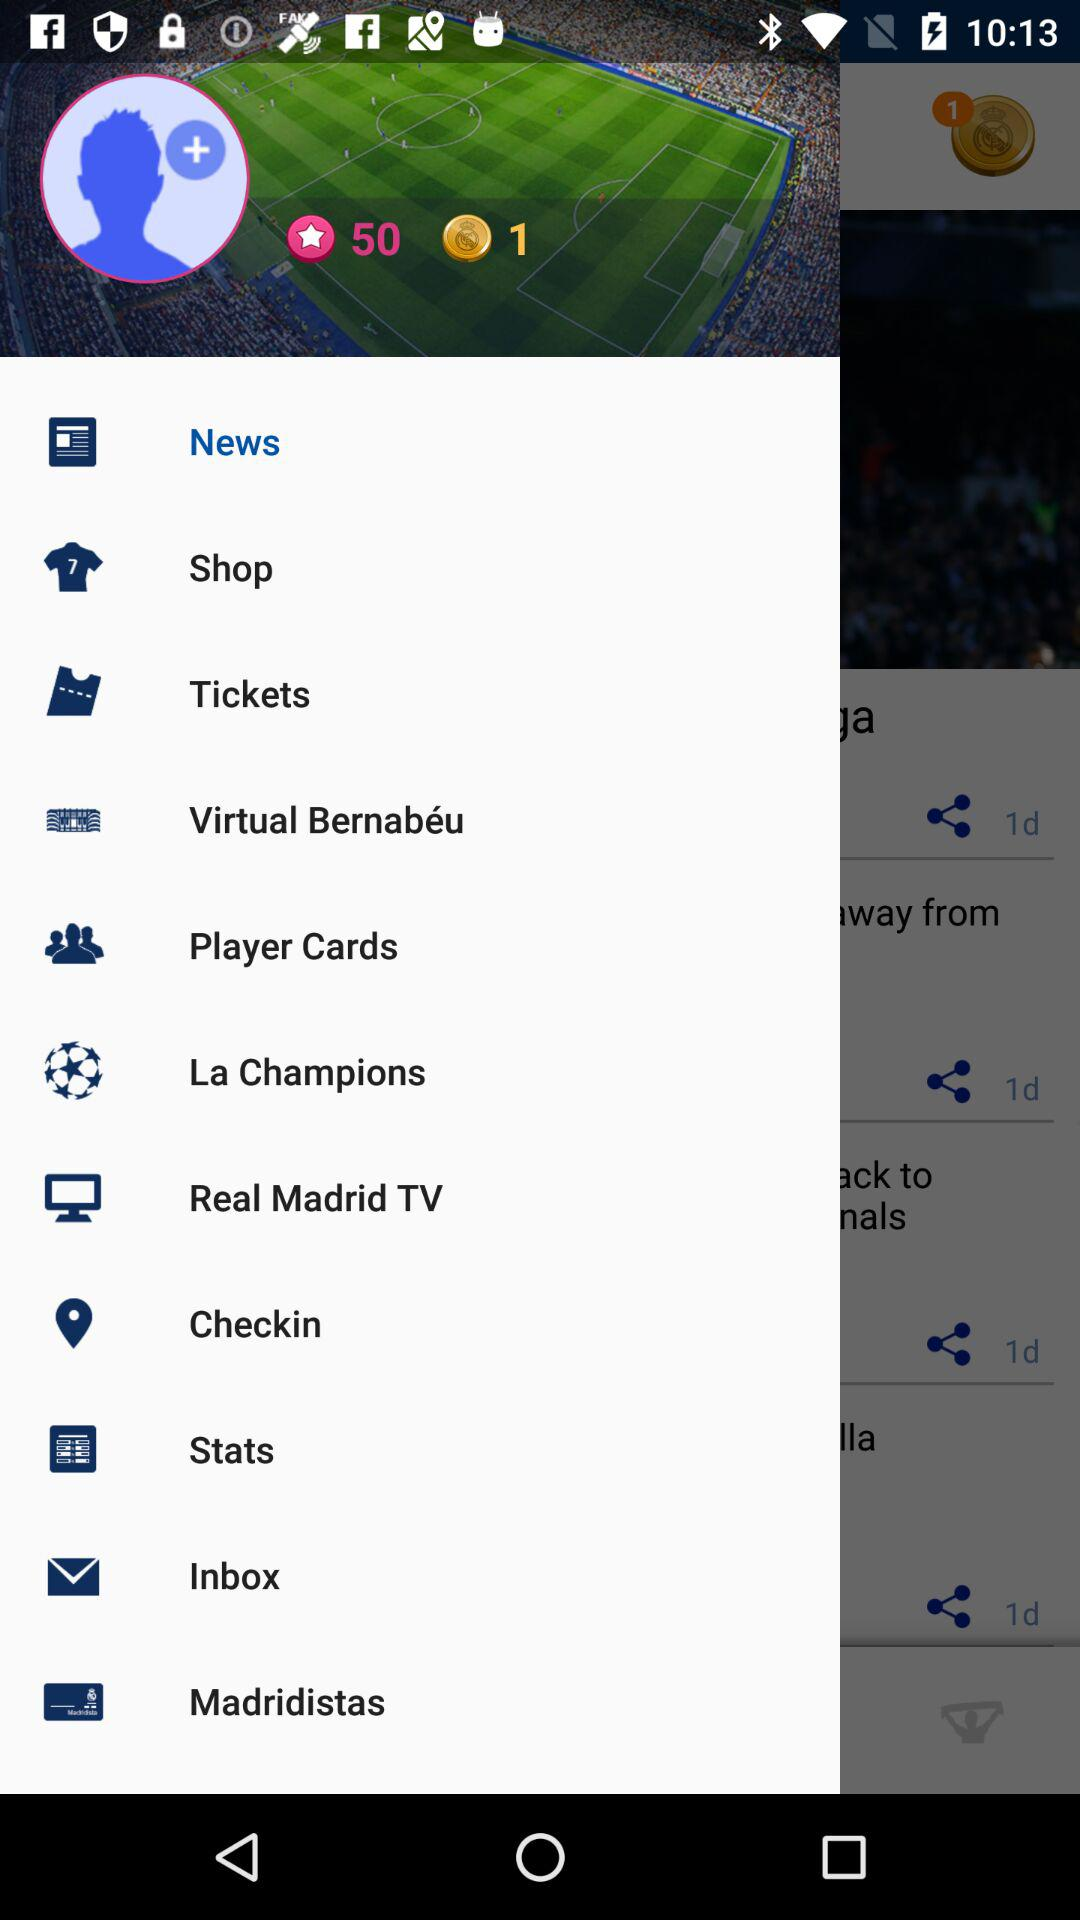How many total stars are available on the screen? The total number of stars available on the screen is 50. 